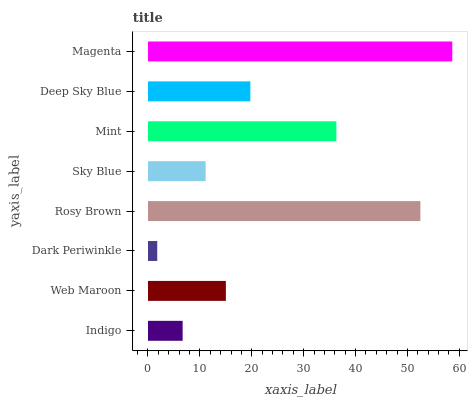Is Dark Periwinkle the minimum?
Answer yes or no. Yes. Is Magenta the maximum?
Answer yes or no. Yes. Is Web Maroon the minimum?
Answer yes or no. No. Is Web Maroon the maximum?
Answer yes or no. No. Is Web Maroon greater than Indigo?
Answer yes or no. Yes. Is Indigo less than Web Maroon?
Answer yes or no. Yes. Is Indigo greater than Web Maroon?
Answer yes or no. No. Is Web Maroon less than Indigo?
Answer yes or no. No. Is Deep Sky Blue the high median?
Answer yes or no. Yes. Is Web Maroon the low median?
Answer yes or no. Yes. Is Dark Periwinkle the high median?
Answer yes or no. No. Is Dark Periwinkle the low median?
Answer yes or no. No. 